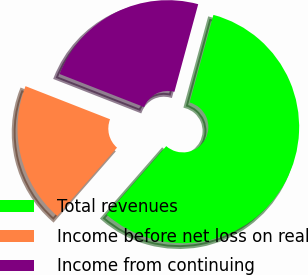Convert chart. <chart><loc_0><loc_0><loc_500><loc_500><pie_chart><fcel>Total revenues<fcel>Income before net loss on real<fcel>Income from continuing<nl><fcel>57.2%<fcel>19.51%<fcel>23.28%<nl></chart> 